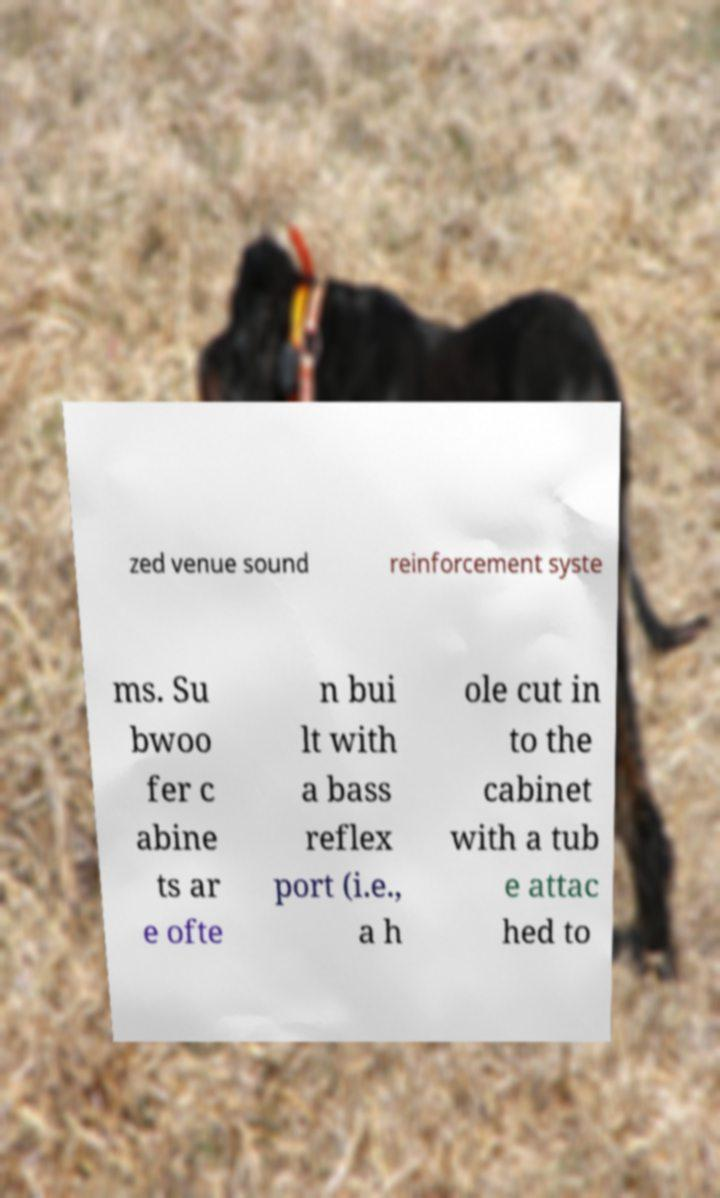Can you read and provide the text displayed in the image?This photo seems to have some interesting text. Can you extract and type it out for me? zed venue sound reinforcement syste ms. Su bwoo fer c abine ts ar e ofte n bui lt with a bass reflex port (i.e., a h ole cut in to the cabinet with a tub e attac hed to 